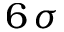<formula> <loc_0><loc_0><loc_500><loc_500>6 \, \sigma</formula> 